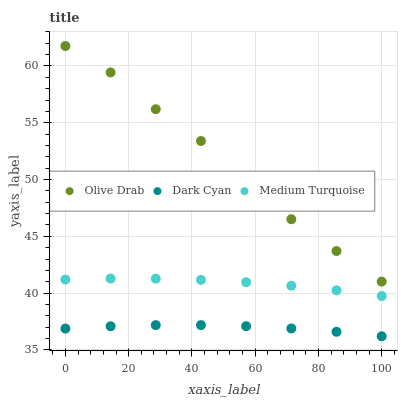Does Dark Cyan have the minimum area under the curve?
Answer yes or no. Yes. Does Olive Drab have the maximum area under the curve?
Answer yes or no. Yes. Does Medium Turquoise have the minimum area under the curve?
Answer yes or no. No. Does Medium Turquoise have the maximum area under the curve?
Answer yes or no. No. Is Medium Turquoise the smoothest?
Answer yes or no. Yes. Is Olive Drab the roughest?
Answer yes or no. Yes. Is Olive Drab the smoothest?
Answer yes or no. No. Is Medium Turquoise the roughest?
Answer yes or no. No. Does Dark Cyan have the lowest value?
Answer yes or no. Yes. Does Medium Turquoise have the lowest value?
Answer yes or no. No. Does Olive Drab have the highest value?
Answer yes or no. Yes. Does Medium Turquoise have the highest value?
Answer yes or no. No. Is Medium Turquoise less than Olive Drab?
Answer yes or no. Yes. Is Olive Drab greater than Medium Turquoise?
Answer yes or no. Yes. Does Medium Turquoise intersect Olive Drab?
Answer yes or no. No. 